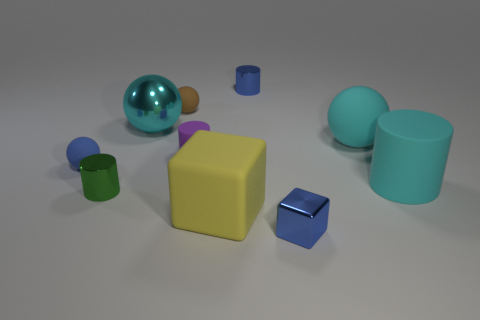What color is the small rubber sphere to the right of the tiny cylinder in front of the cyan rubber cylinder?
Your response must be concise. Brown. How many big things are yellow matte blocks or cyan cylinders?
Provide a succinct answer. 2. There is a thing that is both on the right side of the small blue shiny cylinder and left of the cyan rubber sphere; what color is it?
Give a very brief answer. Blue. Do the brown ball and the cyan cylinder have the same material?
Your answer should be compact. Yes. What is the shape of the big shiny object?
Make the answer very short. Sphere. There is a tiny blue object that is in front of the large yellow cube on the right side of the small brown ball; how many large matte cylinders are behind it?
Ensure brevity in your answer.  1. There is a metallic object that is the same shape as the tiny brown rubber thing; what is its color?
Provide a succinct answer. Cyan. There is a blue metal thing in front of the big cyan ball in front of the large sphere left of the tiny brown object; what is its shape?
Keep it short and to the point. Cube. There is a cyan object that is both behind the tiny purple object and right of the large yellow rubber thing; what is its size?
Your response must be concise. Large. Are there fewer blue cylinders than tiny matte spheres?
Give a very brief answer. Yes. 